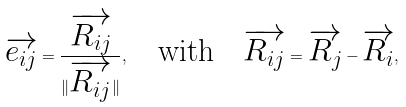<formula> <loc_0><loc_0><loc_500><loc_500>\overrightarrow { e _ { i j } } = \frac { \overrightarrow { R _ { i j } } } { \| \overrightarrow { R _ { i j } } \| } , \quad \text {with} \quad \overrightarrow { R _ { i j } } = \overrightarrow { R _ { j } } - \overrightarrow { R _ { i } } ,</formula> 